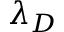<formula> <loc_0><loc_0><loc_500><loc_500>\lambda _ { D }</formula> 